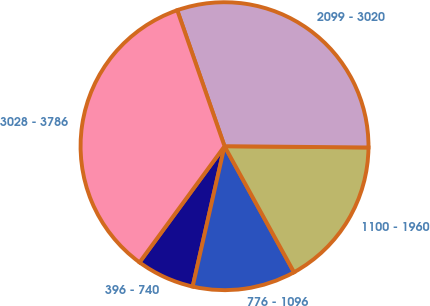<chart> <loc_0><loc_0><loc_500><loc_500><pie_chart><fcel>396 - 740<fcel>776 - 1096<fcel>1100 - 1960<fcel>2099 - 3020<fcel>3028 - 3786<nl><fcel>6.5%<fcel>11.57%<fcel>16.84%<fcel>30.47%<fcel>34.62%<nl></chart> 